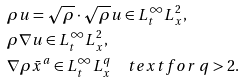Convert formula to latex. <formula><loc_0><loc_0><loc_500><loc_500>& \rho u = \sqrt { \rho } \cdot \sqrt { \rho } u \in L ^ { \infty } _ { t } L ^ { 2 } _ { x } , \\ & \rho \nabla u \in L ^ { \infty } _ { t } L ^ { 2 } _ { x } , \\ & \nabla \rho \bar { x } ^ { a } \in L ^ { \infty } _ { t } L ^ { q } _ { x } \quad t e x t { f o r } \ q > 2 .</formula> 